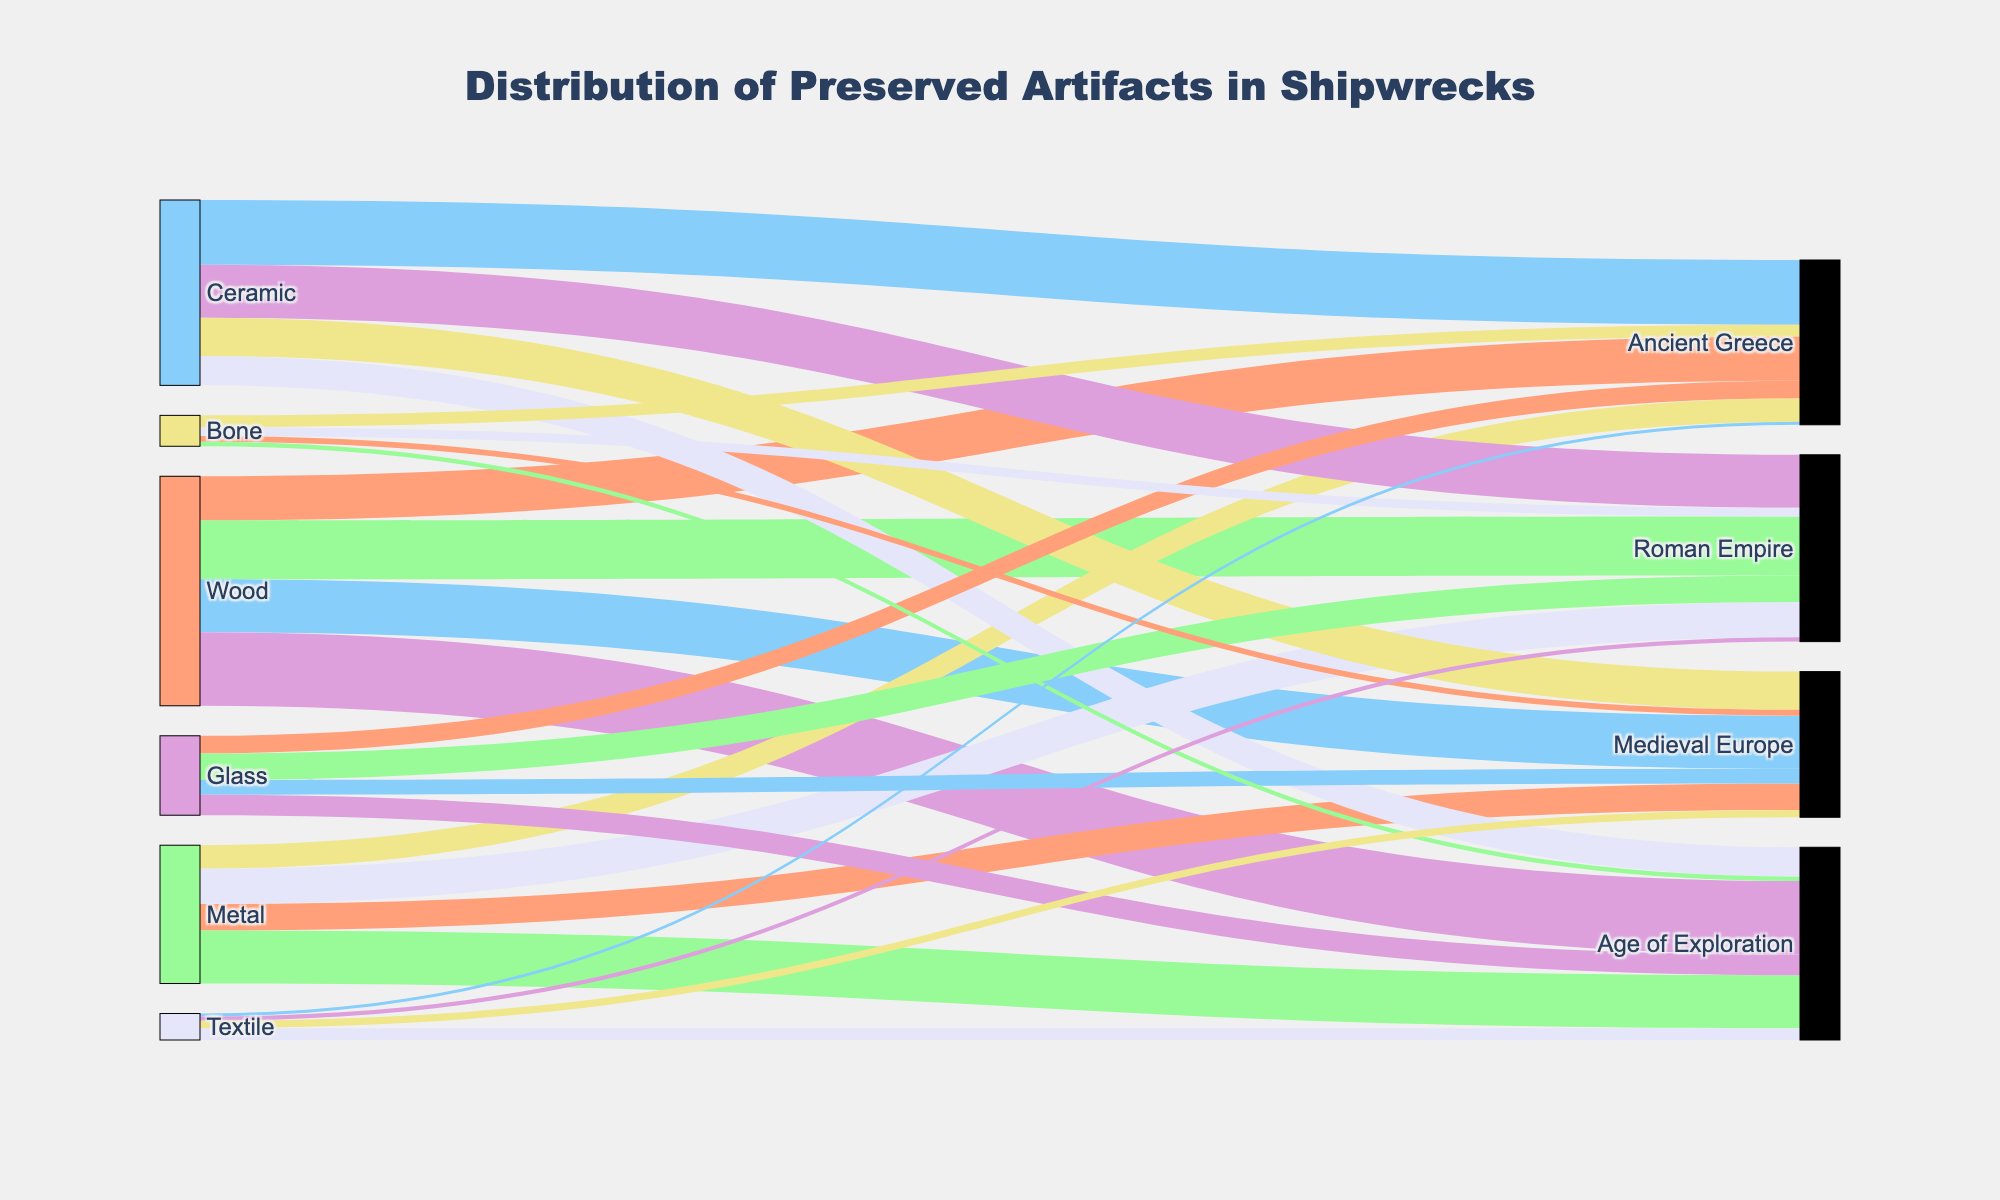How many artifacts from the Age of Exploration are made of ceramic? Locate the "Ceramic" node on the left side of the Sankey diagram and follow its link to the "Age of Exploration" node on the right side. The count should be directly displayed next to the link.
Answer: 100 Which historical period has the highest number of wooden artifacts found? For this, locate all the values linked to the "Wood" node and identify the highest value among the different historical periods.
Answer: Age of Exploration Compare the number of metal artifacts found in the Roman Empire versus the Medieval Europe period. Which one has more? Locate the values linked to the "Metal" node for both "Roman Empire" and "Medieval Europe" and compare them. The Roman Empire should have a higher value.
Answer: Roman Empire What is the total number of textile artifacts found across all historical periods? Add all values linked to the "Textile" node to get the total: 10 (Ancient Greece) + 15 (Roman Empire) + 25 (Medieval Europe) + 40 (Age of Exploration)
Answer: 90 Which material type had the least number of artifacts found in the Ancient Greece period? Look at the values linked to the "Ancient Greece" node on the right side and identify the smallest one.
Answer: Textile How many more ceramic artifacts were found in Ancient Greece compared to Metal artifacts in the same period? Subtract the number of "Metal" artifacts from the number of "Ceramic" artifacts in the "Ancient Greece" period: 220 (Ceramic) - 80 (Metal)
Answer: 140 Is the number of glass artifacts in the Medieval Europe period greater than the number of bone artifacts from Ancient Greece? Compare the "Glass" artifacts’ value from "Medieval Europe" with the "Bone" artifacts’ value from "Ancient Greece". Determine if "Glass" has a higher value.
Answer: No What is the proportion of bone artifacts found in Ancient Greece to the total bone artifacts found across all periods? Calculate the total number of bone artifacts across all periods first: 40 (Ancient Greece) + 30 (Roman Empire) + 20 (Medieval Europe) + 15 (Age of Exploration) = 105. Then find the proportion: 40/105
Answer: 0.38 Which material type has the widest distribution across different historical periods in terms of the number of artifacts found? Look for the material type with values linked to every historical period and take note of their total count.
Answer: Ceramic 